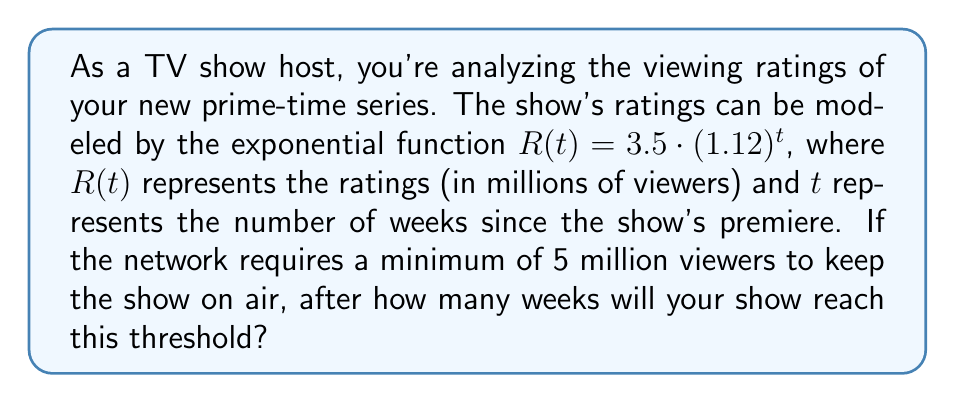Could you help me with this problem? Let's approach this step-by-step:

1) We need to find $t$ when $R(t) = 5$ million viewers.

2) Set up the equation:
   $$ 5 = 3.5 \cdot (1.12)^t $$

3) Divide both sides by 3.5:
   $$ \frac{5}{3.5} = (1.12)^t $$

4) Take the natural logarithm of both sides:
   $$ \ln(\frac{5}{3.5}) = \ln((1.12)^t) $$

5) Use the logarithm property $\ln(a^b) = b\ln(a)$:
   $$ \ln(\frac{5}{3.5}) = t \cdot \ln(1.12) $$

6) Solve for $t$:
   $$ t = \frac{\ln(\frac{5}{3.5})}{\ln(1.12)} $$

7) Calculate:
   $$ t \approx 4.76 $$

8) Since we can't have a fractional number of weeks, we need to round up to the next whole number.
Answer: The show will reach the 5 million viewer threshold after 5 weeks. 